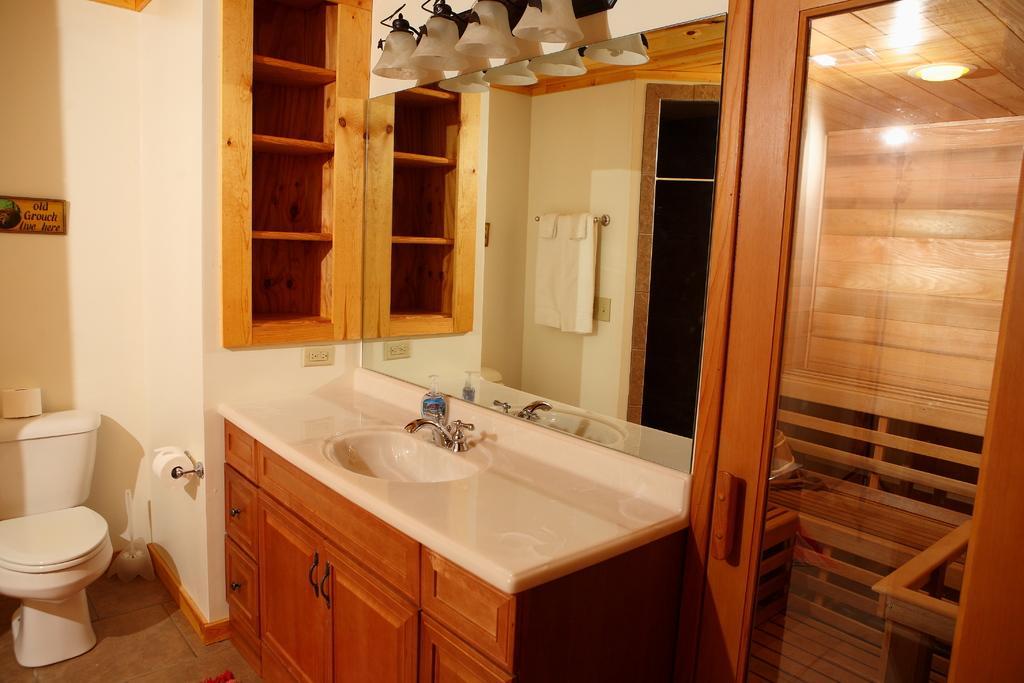In one or two sentences, can you explain what this image depicts? In this image we can see a platform with cupboard. On the platform there is a wash basin with tap. Also there is a bottle. Near to that there is a mirror. In the mirror we can see the reflection of a cupboard, towel with hanger and a door. On the left side there is a toilet with flush. On the flush there is a tissue. On the wall there is a board with something written. Also there is a tissue holder with tissue. On the floor there is a brush. Near to the mirror there are lights. On the right side there is a door. And near to the wash basin there is a cupboard. 